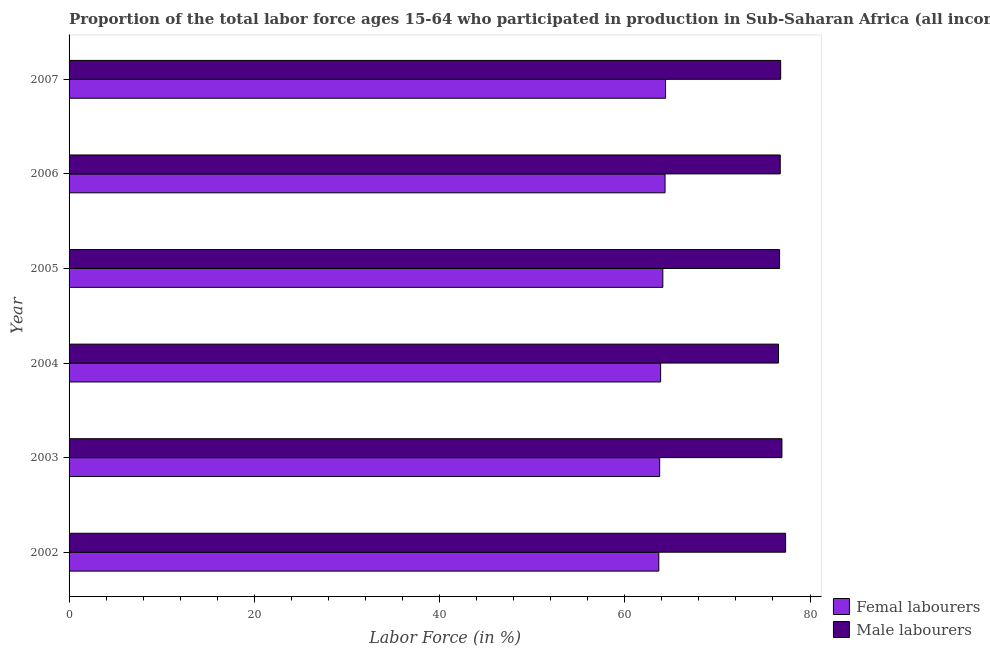How many different coloured bars are there?
Ensure brevity in your answer.  2. Are the number of bars per tick equal to the number of legend labels?
Offer a terse response. Yes. How many bars are there on the 5th tick from the bottom?
Ensure brevity in your answer.  2. In how many cases, is the number of bars for a given year not equal to the number of legend labels?
Offer a very short reply. 0. What is the percentage of male labour force in 2004?
Ensure brevity in your answer.  76.6. Across all years, what is the maximum percentage of male labour force?
Ensure brevity in your answer.  77.36. Across all years, what is the minimum percentage of female labor force?
Your answer should be very brief. 63.67. In which year was the percentage of male labour force maximum?
Provide a short and direct response. 2002. What is the total percentage of female labor force in the graph?
Your answer should be compact. 384.17. What is the difference between the percentage of female labor force in 2002 and that in 2006?
Make the answer very short. -0.68. What is the difference between the percentage of female labor force in 2006 and the percentage of male labour force in 2003?
Ensure brevity in your answer.  -12.62. What is the average percentage of male labour force per year?
Give a very brief answer. 76.88. In the year 2003, what is the difference between the percentage of male labour force and percentage of female labor force?
Keep it short and to the point. 13.2. What is the ratio of the percentage of male labour force in 2003 to that in 2004?
Provide a short and direct response. 1. Is the percentage of male labour force in 2002 less than that in 2003?
Ensure brevity in your answer.  No. Is the difference between the percentage of female labor force in 2003 and 2004 greater than the difference between the percentage of male labour force in 2003 and 2004?
Ensure brevity in your answer.  No. What is the difference between the highest and the second highest percentage of male labour force?
Provide a short and direct response. 0.4. What is the difference between the highest and the lowest percentage of female labor force?
Your response must be concise. 0.73. In how many years, is the percentage of female labor force greater than the average percentage of female labor force taken over all years?
Your answer should be very brief. 3. Is the sum of the percentage of male labour force in 2002 and 2004 greater than the maximum percentage of female labor force across all years?
Provide a short and direct response. Yes. What does the 2nd bar from the top in 2002 represents?
Your response must be concise. Femal labourers. What does the 2nd bar from the bottom in 2007 represents?
Your answer should be very brief. Male labourers. How many years are there in the graph?
Your response must be concise. 6. Does the graph contain any zero values?
Your answer should be very brief. No. Does the graph contain grids?
Provide a short and direct response. No. What is the title of the graph?
Make the answer very short. Proportion of the total labor force ages 15-64 who participated in production in Sub-Saharan Africa (all income levels). What is the label or title of the X-axis?
Make the answer very short. Labor Force (in %). What is the Labor Force (in %) in Femal labourers in 2002?
Provide a succinct answer. 63.67. What is the Labor Force (in %) of Male labourers in 2002?
Your response must be concise. 77.36. What is the Labor Force (in %) in Femal labourers in 2003?
Your response must be concise. 63.77. What is the Labor Force (in %) of Male labourers in 2003?
Keep it short and to the point. 76.97. What is the Labor Force (in %) of Femal labourers in 2004?
Make the answer very short. 63.87. What is the Labor Force (in %) in Male labourers in 2004?
Your response must be concise. 76.6. What is the Labor Force (in %) in Femal labourers in 2005?
Ensure brevity in your answer.  64.11. What is the Labor Force (in %) of Male labourers in 2005?
Your answer should be very brief. 76.71. What is the Labor Force (in %) of Femal labourers in 2006?
Keep it short and to the point. 64.35. What is the Labor Force (in %) in Male labourers in 2006?
Your answer should be compact. 76.79. What is the Labor Force (in %) of Femal labourers in 2007?
Keep it short and to the point. 64.4. What is the Labor Force (in %) in Male labourers in 2007?
Provide a short and direct response. 76.83. Across all years, what is the maximum Labor Force (in %) of Femal labourers?
Your answer should be compact. 64.4. Across all years, what is the maximum Labor Force (in %) in Male labourers?
Your answer should be compact. 77.36. Across all years, what is the minimum Labor Force (in %) of Femal labourers?
Make the answer very short. 63.67. Across all years, what is the minimum Labor Force (in %) of Male labourers?
Make the answer very short. 76.6. What is the total Labor Force (in %) of Femal labourers in the graph?
Ensure brevity in your answer.  384.17. What is the total Labor Force (in %) of Male labourers in the graph?
Provide a succinct answer. 461.26. What is the difference between the Labor Force (in %) in Femal labourers in 2002 and that in 2003?
Offer a terse response. -0.09. What is the difference between the Labor Force (in %) in Male labourers in 2002 and that in 2003?
Your response must be concise. 0.4. What is the difference between the Labor Force (in %) of Femal labourers in 2002 and that in 2004?
Provide a succinct answer. -0.2. What is the difference between the Labor Force (in %) of Male labourers in 2002 and that in 2004?
Ensure brevity in your answer.  0.77. What is the difference between the Labor Force (in %) in Femal labourers in 2002 and that in 2005?
Provide a succinct answer. -0.44. What is the difference between the Labor Force (in %) in Male labourers in 2002 and that in 2005?
Offer a terse response. 0.65. What is the difference between the Labor Force (in %) in Femal labourers in 2002 and that in 2006?
Ensure brevity in your answer.  -0.68. What is the difference between the Labor Force (in %) in Male labourers in 2002 and that in 2006?
Provide a succinct answer. 0.58. What is the difference between the Labor Force (in %) of Femal labourers in 2002 and that in 2007?
Give a very brief answer. -0.73. What is the difference between the Labor Force (in %) in Male labourers in 2002 and that in 2007?
Provide a succinct answer. 0.53. What is the difference between the Labor Force (in %) of Femal labourers in 2003 and that in 2004?
Ensure brevity in your answer.  -0.1. What is the difference between the Labor Force (in %) in Male labourers in 2003 and that in 2004?
Your answer should be very brief. 0.37. What is the difference between the Labor Force (in %) of Femal labourers in 2003 and that in 2005?
Your answer should be compact. -0.34. What is the difference between the Labor Force (in %) of Male labourers in 2003 and that in 2005?
Make the answer very short. 0.26. What is the difference between the Labor Force (in %) of Femal labourers in 2003 and that in 2006?
Make the answer very short. -0.58. What is the difference between the Labor Force (in %) in Male labourers in 2003 and that in 2006?
Offer a terse response. 0.18. What is the difference between the Labor Force (in %) of Femal labourers in 2003 and that in 2007?
Give a very brief answer. -0.64. What is the difference between the Labor Force (in %) in Male labourers in 2003 and that in 2007?
Your answer should be very brief. 0.14. What is the difference between the Labor Force (in %) of Femal labourers in 2004 and that in 2005?
Offer a very short reply. -0.24. What is the difference between the Labor Force (in %) of Male labourers in 2004 and that in 2005?
Your answer should be very brief. -0.12. What is the difference between the Labor Force (in %) of Femal labourers in 2004 and that in 2006?
Give a very brief answer. -0.48. What is the difference between the Labor Force (in %) in Male labourers in 2004 and that in 2006?
Your answer should be very brief. -0.19. What is the difference between the Labor Force (in %) of Femal labourers in 2004 and that in 2007?
Your answer should be compact. -0.53. What is the difference between the Labor Force (in %) of Male labourers in 2004 and that in 2007?
Provide a short and direct response. -0.23. What is the difference between the Labor Force (in %) in Femal labourers in 2005 and that in 2006?
Your answer should be very brief. -0.24. What is the difference between the Labor Force (in %) of Male labourers in 2005 and that in 2006?
Offer a very short reply. -0.07. What is the difference between the Labor Force (in %) in Femal labourers in 2005 and that in 2007?
Your answer should be very brief. -0.29. What is the difference between the Labor Force (in %) of Male labourers in 2005 and that in 2007?
Ensure brevity in your answer.  -0.12. What is the difference between the Labor Force (in %) in Femal labourers in 2006 and that in 2007?
Your answer should be compact. -0.06. What is the difference between the Labor Force (in %) of Male labourers in 2006 and that in 2007?
Your answer should be compact. -0.05. What is the difference between the Labor Force (in %) of Femal labourers in 2002 and the Labor Force (in %) of Male labourers in 2003?
Ensure brevity in your answer.  -13.3. What is the difference between the Labor Force (in %) of Femal labourers in 2002 and the Labor Force (in %) of Male labourers in 2004?
Offer a terse response. -12.93. What is the difference between the Labor Force (in %) of Femal labourers in 2002 and the Labor Force (in %) of Male labourers in 2005?
Provide a short and direct response. -13.04. What is the difference between the Labor Force (in %) in Femal labourers in 2002 and the Labor Force (in %) in Male labourers in 2006?
Make the answer very short. -13.11. What is the difference between the Labor Force (in %) in Femal labourers in 2002 and the Labor Force (in %) in Male labourers in 2007?
Your answer should be very brief. -13.16. What is the difference between the Labor Force (in %) in Femal labourers in 2003 and the Labor Force (in %) in Male labourers in 2004?
Give a very brief answer. -12.83. What is the difference between the Labor Force (in %) in Femal labourers in 2003 and the Labor Force (in %) in Male labourers in 2005?
Keep it short and to the point. -12.95. What is the difference between the Labor Force (in %) of Femal labourers in 2003 and the Labor Force (in %) of Male labourers in 2006?
Ensure brevity in your answer.  -13.02. What is the difference between the Labor Force (in %) in Femal labourers in 2003 and the Labor Force (in %) in Male labourers in 2007?
Your answer should be very brief. -13.07. What is the difference between the Labor Force (in %) of Femal labourers in 2004 and the Labor Force (in %) of Male labourers in 2005?
Offer a very short reply. -12.84. What is the difference between the Labor Force (in %) of Femal labourers in 2004 and the Labor Force (in %) of Male labourers in 2006?
Make the answer very short. -12.92. What is the difference between the Labor Force (in %) in Femal labourers in 2004 and the Labor Force (in %) in Male labourers in 2007?
Ensure brevity in your answer.  -12.96. What is the difference between the Labor Force (in %) of Femal labourers in 2005 and the Labor Force (in %) of Male labourers in 2006?
Provide a short and direct response. -12.68. What is the difference between the Labor Force (in %) of Femal labourers in 2005 and the Labor Force (in %) of Male labourers in 2007?
Give a very brief answer. -12.72. What is the difference between the Labor Force (in %) of Femal labourers in 2006 and the Labor Force (in %) of Male labourers in 2007?
Make the answer very short. -12.48. What is the average Labor Force (in %) in Femal labourers per year?
Your response must be concise. 64.03. What is the average Labor Force (in %) in Male labourers per year?
Give a very brief answer. 76.88. In the year 2002, what is the difference between the Labor Force (in %) of Femal labourers and Labor Force (in %) of Male labourers?
Offer a very short reply. -13.69. In the year 2003, what is the difference between the Labor Force (in %) of Femal labourers and Labor Force (in %) of Male labourers?
Your answer should be compact. -13.2. In the year 2004, what is the difference between the Labor Force (in %) in Femal labourers and Labor Force (in %) in Male labourers?
Your response must be concise. -12.73. In the year 2005, what is the difference between the Labor Force (in %) of Femal labourers and Labor Force (in %) of Male labourers?
Provide a short and direct response. -12.61. In the year 2006, what is the difference between the Labor Force (in %) in Femal labourers and Labor Force (in %) in Male labourers?
Give a very brief answer. -12.44. In the year 2007, what is the difference between the Labor Force (in %) in Femal labourers and Labor Force (in %) in Male labourers?
Ensure brevity in your answer.  -12.43. What is the ratio of the Labor Force (in %) in Femal labourers in 2002 to that in 2003?
Your answer should be compact. 1. What is the ratio of the Labor Force (in %) of Male labourers in 2002 to that in 2003?
Offer a terse response. 1.01. What is the ratio of the Labor Force (in %) in Femal labourers in 2002 to that in 2004?
Keep it short and to the point. 1. What is the ratio of the Labor Force (in %) of Male labourers in 2002 to that in 2004?
Provide a succinct answer. 1.01. What is the ratio of the Labor Force (in %) of Femal labourers in 2002 to that in 2005?
Make the answer very short. 0.99. What is the ratio of the Labor Force (in %) of Male labourers in 2002 to that in 2005?
Make the answer very short. 1.01. What is the ratio of the Labor Force (in %) of Male labourers in 2002 to that in 2006?
Offer a very short reply. 1.01. What is the ratio of the Labor Force (in %) of Male labourers in 2002 to that in 2007?
Provide a short and direct response. 1.01. What is the ratio of the Labor Force (in %) of Femal labourers in 2003 to that in 2004?
Keep it short and to the point. 1. What is the ratio of the Labor Force (in %) in Male labourers in 2003 to that in 2004?
Your answer should be compact. 1. What is the ratio of the Labor Force (in %) of Femal labourers in 2003 to that in 2005?
Keep it short and to the point. 0.99. What is the ratio of the Labor Force (in %) in Male labourers in 2003 to that in 2005?
Your response must be concise. 1. What is the ratio of the Labor Force (in %) in Femal labourers in 2003 to that in 2006?
Your answer should be very brief. 0.99. What is the ratio of the Labor Force (in %) of Male labourers in 2003 to that in 2006?
Offer a terse response. 1. What is the ratio of the Labor Force (in %) in Male labourers in 2004 to that in 2006?
Keep it short and to the point. 1. What is the ratio of the Labor Force (in %) of Femal labourers in 2004 to that in 2007?
Keep it short and to the point. 0.99. What is the ratio of the Labor Force (in %) of Femal labourers in 2005 to that in 2006?
Offer a terse response. 1. What is the ratio of the Labor Force (in %) of Male labourers in 2005 to that in 2006?
Your response must be concise. 1. What is the ratio of the Labor Force (in %) in Femal labourers in 2006 to that in 2007?
Offer a very short reply. 1. What is the ratio of the Labor Force (in %) in Male labourers in 2006 to that in 2007?
Provide a short and direct response. 1. What is the difference between the highest and the second highest Labor Force (in %) of Femal labourers?
Your answer should be very brief. 0.06. What is the difference between the highest and the second highest Labor Force (in %) of Male labourers?
Make the answer very short. 0.4. What is the difference between the highest and the lowest Labor Force (in %) in Femal labourers?
Your answer should be very brief. 0.73. What is the difference between the highest and the lowest Labor Force (in %) in Male labourers?
Offer a terse response. 0.77. 